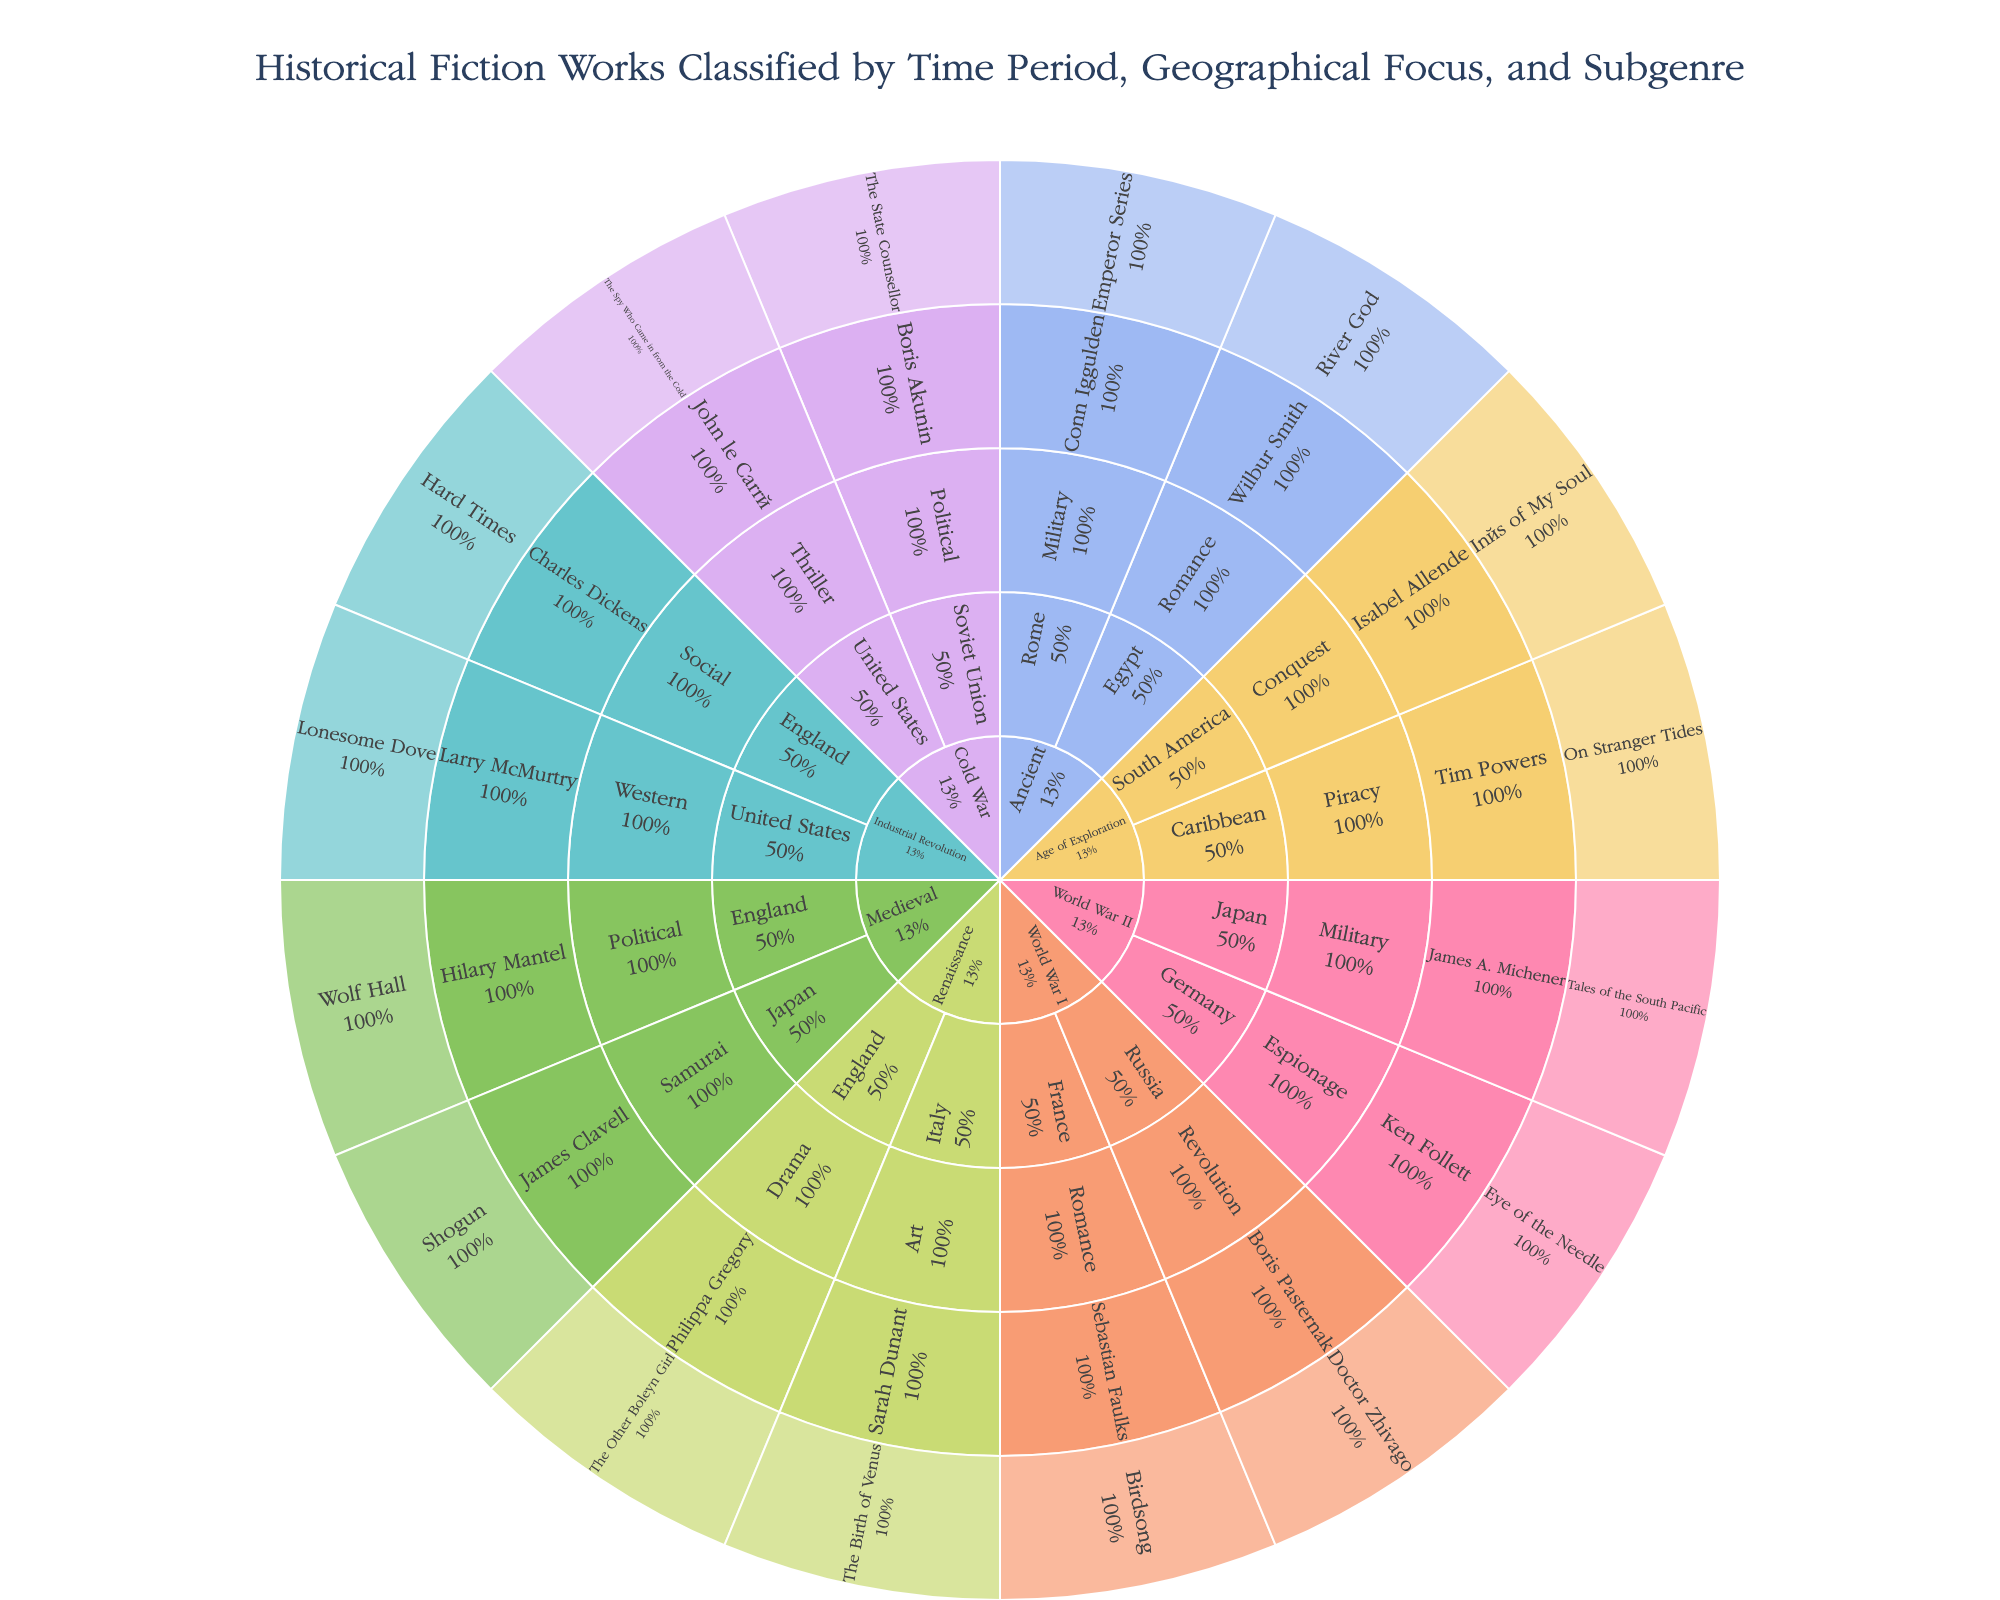Which historical fiction work focuses on the Renaissance period with a geographical focus on Italy? Look for the 'Renaissance' time period, then find the 'Italy' section within it and check the subgenres and works listed.
Answer: The Birth of Venus How many works are focused on World War II? Identify the 'World War II' section and count the number of works listed under its subcategories.
Answer: 2 Which author wrote a work classified under the Industrial Revolution period in the United States with the subgenre of Western? Navigate to the 'Industrial Revolution' period, then to 'United States,' and find the 'Western' subgenre to see the author.
Answer: Larry McMurtry What percentage of the works in the Ancient period are focused on Rome? Look at the 'Ancient' period and sum up the works under it, then find how many of those are focused on 'Rome' and divide by the total. Multiply by 100 for the percentage.
Answer: 50% Compare the number of works classified under 'Romance' across all time periods. Which time periods contain works of this subgenre, and how do they compare? Check all time periods and find the 'Romance' subgenre within each to count works, then compare these counts.
Answer: Ancient (1), World War I (1) What is the title of the work written by Ken Follett? Search for Ken Follett in the plot and see the title of the work associated with this author.
Answer: Eye of the Needle In which time period and geographical focus is the author Hilary Mantel's work categorized? Locate Hilary Mantel in the plot and trace back to see the time period and geographical focus.
Answer: Medieval, England Which subgenre is most abundant in the 'Cold War' period and how many works are in that subgenre? Explore the 'Cold War' period, identify the subgenres, and count the works within each subgenre.
Answer: Thriller (1), Political (1) Is there any author with more than one work listed in the plot? Review all the authors across different sections to see if any author appears more than once.
Answer: No 